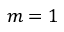<formula> <loc_0><loc_0><loc_500><loc_500>m = 1</formula> 